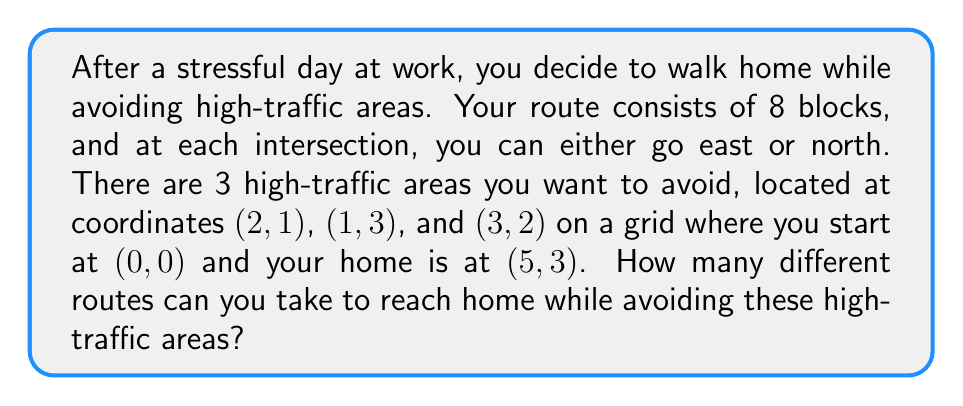Can you solve this math problem? Let's approach this step-by-step:

1) First, we need to understand that without restrictions, the total number of routes would be $\binom{8}{5}$ or $\binom{8}{3}$, as we need to choose 5 east moves out of 8 total moves.

2) However, we need to subtract the routes that pass through the high-traffic areas.

3) Let's count the routes through each high-traffic point:

   a) For (2,1): $\binom{3}{2} \cdot \binom{5}{3} = 30$ routes
   b) For (1,3): $\binom{4}{1} \cdot \binom{4}{2} = 24$ routes
   c) For (3,2): $\binom{5}{3} \cdot \binom{3}{1} = 30$ routes

4) However, some routes might be counted twice if they pass through two high-traffic areas. We need to add these back:

   a) Through (2,1) and (3,2): $\binom{3}{2} \cdot \binom{2}{1} \cdot \binom{3}{1} = 9$ routes
   b) Through (1,3) and (3,2): $\binom{4}{1} \cdot \binom{1}{1} \cdot \binom{3}{1} = 12$ routes
   c) Through (2,1) and (1,3): 0 routes (impossible to pass through both)

5) No route passes through all three points, so we don't need to subtract anything further.

6) Therefore, the total number of valid routes is:

   $$\binom{8}{5} - (30 + 24 + 30) + (9 + 12) = 56 - 84 + 21 = -7$$

7) However, we can't have a negative number of routes. This means we've overcounted the blocked routes.

8) The correct approach is to count the valid routes directly:

   a) Routes passing below (2,1) and left of (3,2): $\binom{5}{3} = 10$ routes
   b) Routes passing above (2,1), below (1,3), and right of (3,2): $\binom{4}{2} = 6$ routes

9) The total number of valid routes is the sum of these: $10 + 6 = 16$
Answer: 16 routes 